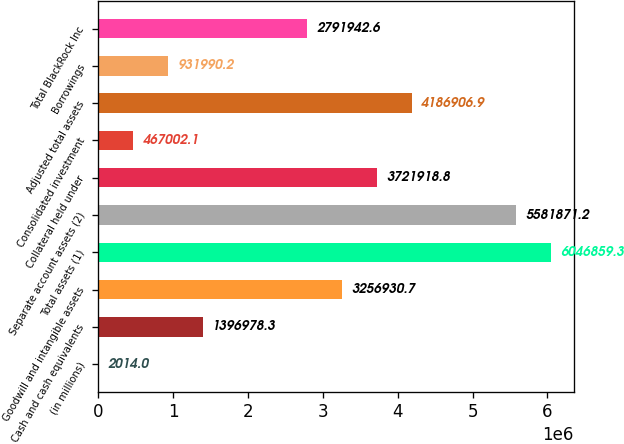<chart> <loc_0><loc_0><loc_500><loc_500><bar_chart><fcel>(in millions)<fcel>Cash and cash equivalents<fcel>Goodwill and intangible assets<fcel>Total assets (1)<fcel>Separate account assets (2)<fcel>Collateral held under<fcel>Consolidated investment<fcel>Adjusted total assets<fcel>Borrowings<fcel>Total BlackRock Inc<nl><fcel>2014<fcel>1.39698e+06<fcel>3.25693e+06<fcel>6.04686e+06<fcel>5.58187e+06<fcel>3.72192e+06<fcel>467002<fcel>4.18691e+06<fcel>931990<fcel>2.79194e+06<nl></chart> 